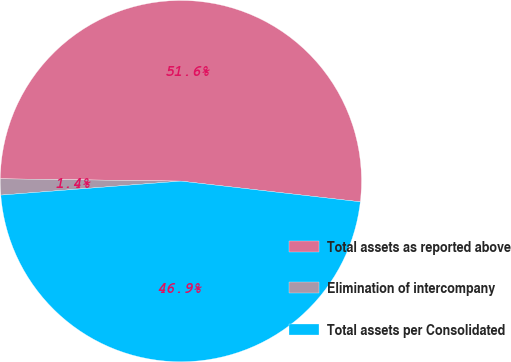Convert chart to OTSL. <chart><loc_0><loc_0><loc_500><loc_500><pie_chart><fcel>Total assets as reported above<fcel>Elimination of intercompany<fcel>Total assets per Consolidated<nl><fcel>51.63%<fcel>1.44%<fcel>46.94%<nl></chart> 